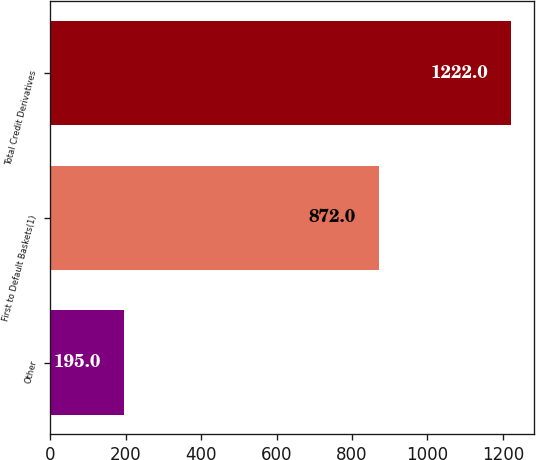<chart> <loc_0><loc_0><loc_500><loc_500><bar_chart><fcel>Other<fcel>First to Default Baskets(1)<fcel>Total Credit Derivatives<nl><fcel>195<fcel>872<fcel>1222<nl></chart> 